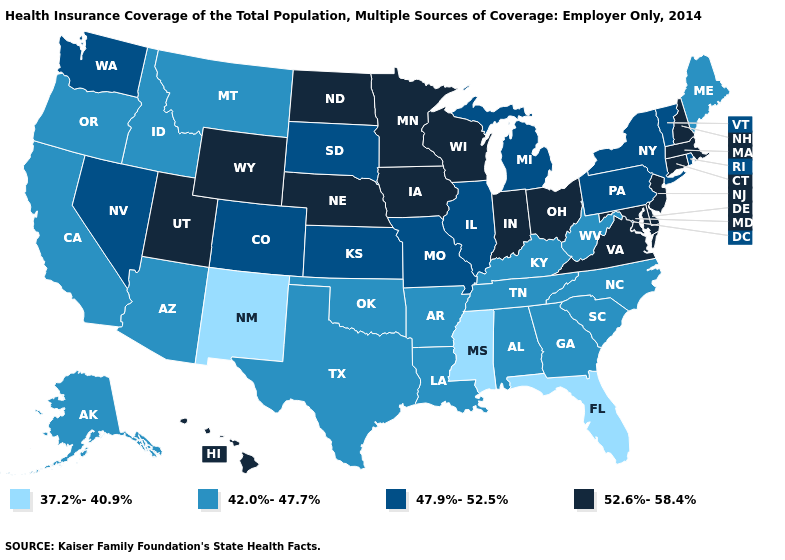What is the highest value in states that border Indiana?
Write a very short answer. 52.6%-58.4%. What is the value of Montana?
Give a very brief answer. 42.0%-47.7%. What is the lowest value in the Northeast?
Keep it brief. 42.0%-47.7%. What is the value of Illinois?
Be succinct. 47.9%-52.5%. Does the first symbol in the legend represent the smallest category?
Short answer required. Yes. What is the lowest value in the USA?
Write a very short answer. 37.2%-40.9%. Among the states that border Rhode Island , which have the lowest value?
Quick response, please. Connecticut, Massachusetts. Does Utah have the highest value in the West?
Concise answer only. Yes. What is the value of Kansas?
Answer briefly. 47.9%-52.5%. Does the first symbol in the legend represent the smallest category?
Give a very brief answer. Yes. Does Minnesota have a higher value than Ohio?
Write a very short answer. No. What is the lowest value in the USA?
Keep it brief. 37.2%-40.9%. What is the value of West Virginia?
Give a very brief answer. 42.0%-47.7%. Name the states that have a value in the range 37.2%-40.9%?
Short answer required. Florida, Mississippi, New Mexico. Among the states that border New York , which have the highest value?
Write a very short answer. Connecticut, Massachusetts, New Jersey. 